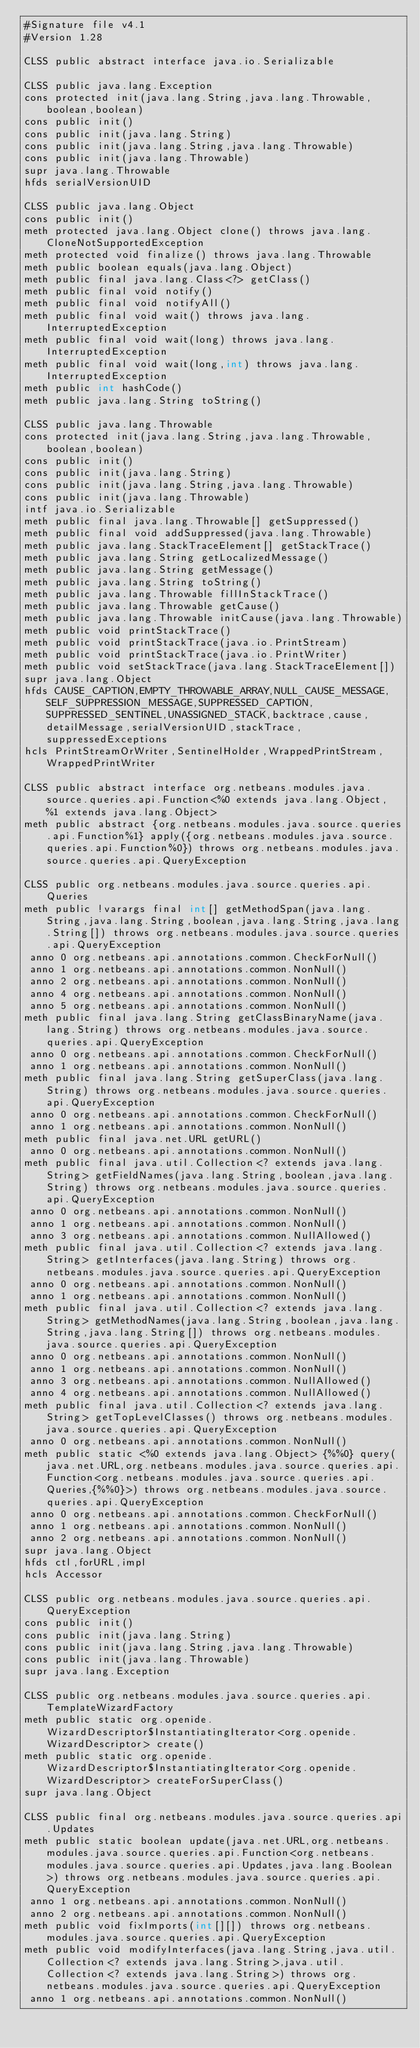Convert code to text. <code><loc_0><loc_0><loc_500><loc_500><_SML_>#Signature file v4.1
#Version 1.28

CLSS public abstract interface java.io.Serializable

CLSS public java.lang.Exception
cons protected init(java.lang.String,java.lang.Throwable,boolean,boolean)
cons public init()
cons public init(java.lang.String)
cons public init(java.lang.String,java.lang.Throwable)
cons public init(java.lang.Throwable)
supr java.lang.Throwable
hfds serialVersionUID

CLSS public java.lang.Object
cons public init()
meth protected java.lang.Object clone() throws java.lang.CloneNotSupportedException
meth protected void finalize() throws java.lang.Throwable
meth public boolean equals(java.lang.Object)
meth public final java.lang.Class<?> getClass()
meth public final void notify()
meth public final void notifyAll()
meth public final void wait() throws java.lang.InterruptedException
meth public final void wait(long) throws java.lang.InterruptedException
meth public final void wait(long,int) throws java.lang.InterruptedException
meth public int hashCode()
meth public java.lang.String toString()

CLSS public java.lang.Throwable
cons protected init(java.lang.String,java.lang.Throwable,boolean,boolean)
cons public init()
cons public init(java.lang.String)
cons public init(java.lang.String,java.lang.Throwable)
cons public init(java.lang.Throwable)
intf java.io.Serializable
meth public final java.lang.Throwable[] getSuppressed()
meth public final void addSuppressed(java.lang.Throwable)
meth public java.lang.StackTraceElement[] getStackTrace()
meth public java.lang.String getLocalizedMessage()
meth public java.lang.String getMessage()
meth public java.lang.String toString()
meth public java.lang.Throwable fillInStackTrace()
meth public java.lang.Throwable getCause()
meth public java.lang.Throwable initCause(java.lang.Throwable)
meth public void printStackTrace()
meth public void printStackTrace(java.io.PrintStream)
meth public void printStackTrace(java.io.PrintWriter)
meth public void setStackTrace(java.lang.StackTraceElement[])
supr java.lang.Object
hfds CAUSE_CAPTION,EMPTY_THROWABLE_ARRAY,NULL_CAUSE_MESSAGE,SELF_SUPPRESSION_MESSAGE,SUPPRESSED_CAPTION,SUPPRESSED_SENTINEL,UNASSIGNED_STACK,backtrace,cause,detailMessage,serialVersionUID,stackTrace,suppressedExceptions
hcls PrintStreamOrWriter,SentinelHolder,WrappedPrintStream,WrappedPrintWriter

CLSS public abstract interface org.netbeans.modules.java.source.queries.api.Function<%0 extends java.lang.Object, %1 extends java.lang.Object>
meth public abstract {org.netbeans.modules.java.source.queries.api.Function%1} apply({org.netbeans.modules.java.source.queries.api.Function%0}) throws org.netbeans.modules.java.source.queries.api.QueryException

CLSS public org.netbeans.modules.java.source.queries.api.Queries
meth public !varargs final int[] getMethodSpan(java.lang.String,java.lang.String,boolean,java.lang.String,java.lang.String[]) throws org.netbeans.modules.java.source.queries.api.QueryException
 anno 0 org.netbeans.api.annotations.common.CheckForNull()
 anno 1 org.netbeans.api.annotations.common.NonNull()
 anno 2 org.netbeans.api.annotations.common.NonNull()
 anno 4 org.netbeans.api.annotations.common.NonNull()
 anno 5 org.netbeans.api.annotations.common.NonNull()
meth public final java.lang.String getClassBinaryName(java.lang.String) throws org.netbeans.modules.java.source.queries.api.QueryException
 anno 0 org.netbeans.api.annotations.common.CheckForNull()
 anno 1 org.netbeans.api.annotations.common.NonNull()
meth public final java.lang.String getSuperClass(java.lang.String) throws org.netbeans.modules.java.source.queries.api.QueryException
 anno 0 org.netbeans.api.annotations.common.CheckForNull()
 anno 1 org.netbeans.api.annotations.common.NonNull()
meth public final java.net.URL getURL()
 anno 0 org.netbeans.api.annotations.common.NonNull()
meth public final java.util.Collection<? extends java.lang.String> getFieldNames(java.lang.String,boolean,java.lang.String) throws org.netbeans.modules.java.source.queries.api.QueryException
 anno 0 org.netbeans.api.annotations.common.NonNull()
 anno 1 org.netbeans.api.annotations.common.NonNull()
 anno 3 org.netbeans.api.annotations.common.NullAllowed()
meth public final java.util.Collection<? extends java.lang.String> getInterfaces(java.lang.String) throws org.netbeans.modules.java.source.queries.api.QueryException
 anno 0 org.netbeans.api.annotations.common.NonNull()
 anno 1 org.netbeans.api.annotations.common.NonNull()
meth public final java.util.Collection<? extends java.lang.String> getMethodNames(java.lang.String,boolean,java.lang.String,java.lang.String[]) throws org.netbeans.modules.java.source.queries.api.QueryException
 anno 0 org.netbeans.api.annotations.common.NonNull()
 anno 1 org.netbeans.api.annotations.common.NonNull()
 anno 3 org.netbeans.api.annotations.common.NullAllowed()
 anno 4 org.netbeans.api.annotations.common.NullAllowed()
meth public final java.util.Collection<? extends java.lang.String> getTopLevelClasses() throws org.netbeans.modules.java.source.queries.api.QueryException
 anno 0 org.netbeans.api.annotations.common.NonNull()
meth public static <%0 extends java.lang.Object> {%%0} query(java.net.URL,org.netbeans.modules.java.source.queries.api.Function<org.netbeans.modules.java.source.queries.api.Queries,{%%0}>) throws org.netbeans.modules.java.source.queries.api.QueryException
 anno 0 org.netbeans.api.annotations.common.CheckForNull()
 anno 1 org.netbeans.api.annotations.common.NonNull()
 anno 2 org.netbeans.api.annotations.common.NonNull()
supr java.lang.Object
hfds ctl,forURL,impl
hcls Accessor

CLSS public org.netbeans.modules.java.source.queries.api.QueryException
cons public init()
cons public init(java.lang.String)
cons public init(java.lang.String,java.lang.Throwable)
cons public init(java.lang.Throwable)
supr java.lang.Exception

CLSS public org.netbeans.modules.java.source.queries.api.TemplateWizardFactory
meth public static org.openide.WizardDescriptor$InstantiatingIterator<org.openide.WizardDescriptor> create()
meth public static org.openide.WizardDescriptor$InstantiatingIterator<org.openide.WizardDescriptor> createForSuperClass()
supr java.lang.Object

CLSS public final org.netbeans.modules.java.source.queries.api.Updates
meth public static boolean update(java.net.URL,org.netbeans.modules.java.source.queries.api.Function<org.netbeans.modules.java.source.queries.api.Updates,java.lang.Boolean>) throws org.netbeans.modules.java.source.queries.api.QueryException
 anno 1 org.netbeans.api.annotations.common.NonNull()
 anno 2 org.netbeans.api.annotations.common.NonNull()
meth public void fixImports(int[][]) throws org.netbeans.modules.java.source.queries.api.QueryException
meth public void modifyInterfaces(java.lang.String,java.util.Collection<? extends java.lang.String>,java.util.Collection<? extends java.lang.String>) throws org.netbeans.modules.java.source.queries.api.QueryException
 anno 1 org.netbeans.api.annotations.common.NonNull()</code> 